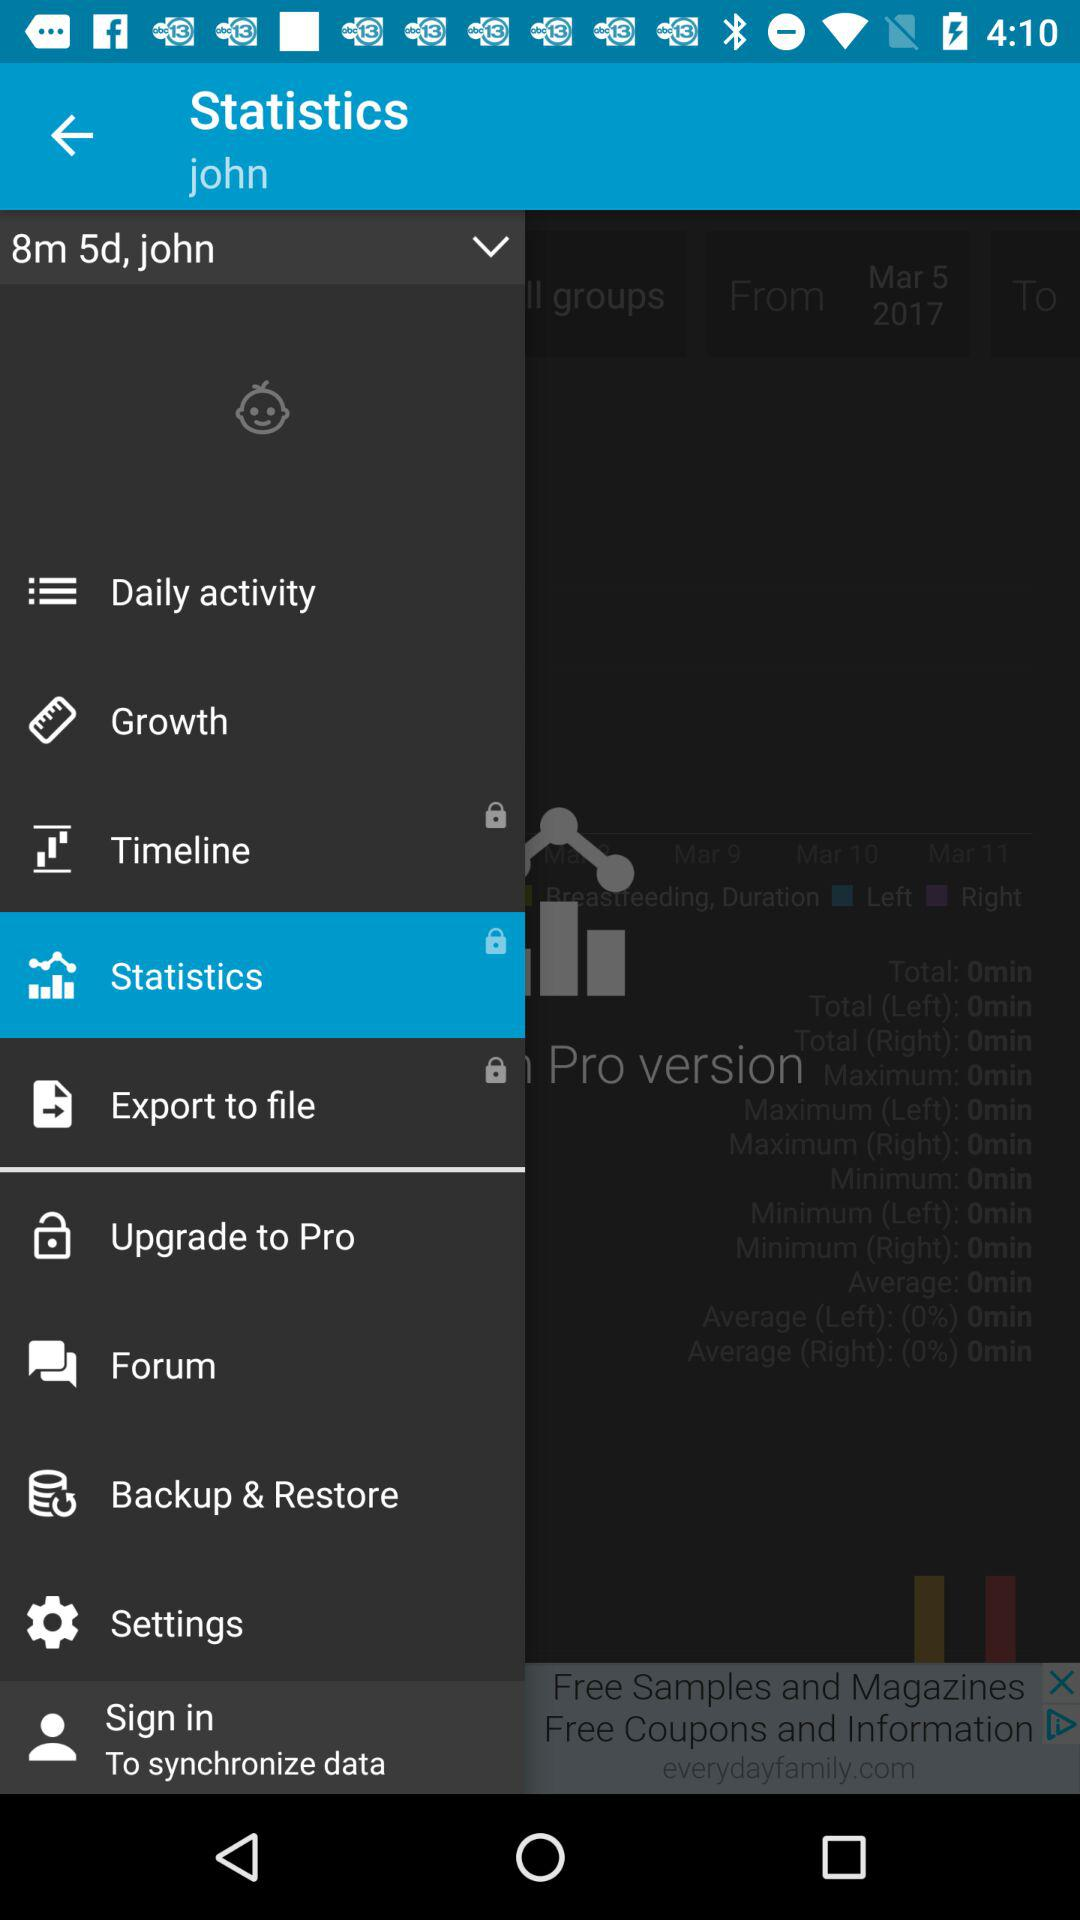What is the user name? The user name is John. 